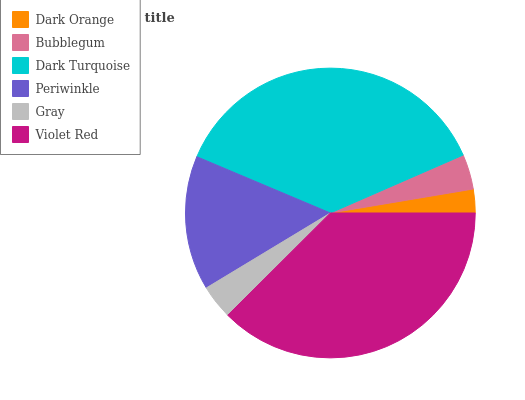Is Dark Orange the minimum?
Answer yes or no. Yes. Is Violet Red the maximum?
Answer yes or no. Yes. Is Bubblegum the minimum?
Answer yes or no. No. Is Bubblegum the maximum?
Answer yes or no. No. Is Bubblegum greater than Dark Orange?
Answer yes or no. Yes. Is Dark Orange less than Bubblegum?
Answer yes or no. Yes. Is Dark Orange greater than Bubblegum?
Answer yes or no. No. Is Bubblegum less than Dark Orange?
Answer yes or no. No. Is Periwinkle the high median?
Answer yes or no. Yes. Is Bubblegum the low median?
Answer yes or no. Yes. Is Violet Red the high median?
Answer yes or no. No. Is Violet Red the low median?
Answer yes or no. No. 